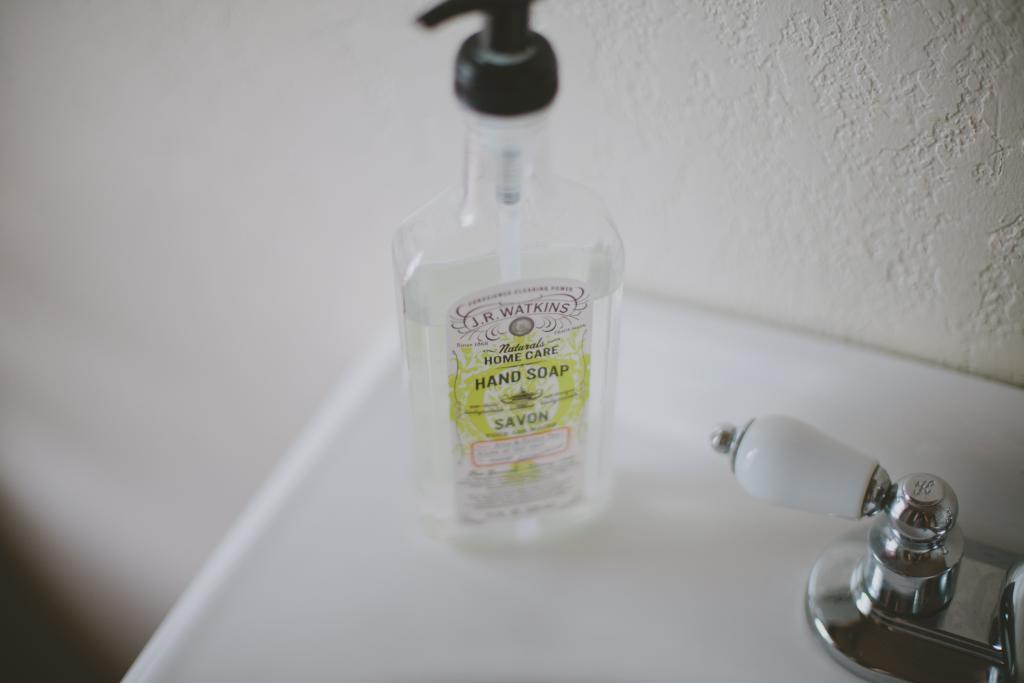What object can be seen in the image? There is a bottle in the image. What feature is present for dispensing liquid? There is a tap in the image. What is the color of the platform in the image? The platform is white in color. What can be seen in the background of the image? There is a wall in the background of the image. What type of surprise is being prepared in the middle of the image? There is no surprise being prepared in the image; it only contains a bottle, a tap, a white platform, and a wall in the background. What kind of food can be seen on the platform in the image? There is no food present on the platform in the image; it only contains a bottle and a tap. 